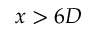<formula> <loc_0><loc_0><loc_500><loc_500>x > 6 D</formula> 